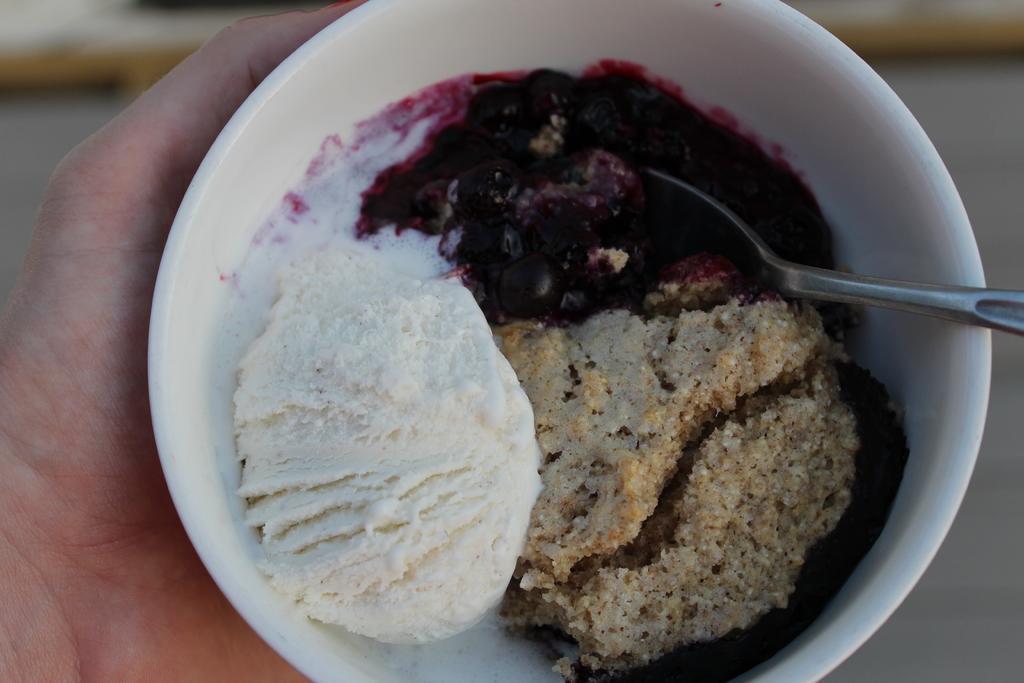In one or two sentences, can you explain what this image depicts? The picture consists of a person's hand, holding a bowl. In the bowl there are food item and spoon. The background is blurred. 